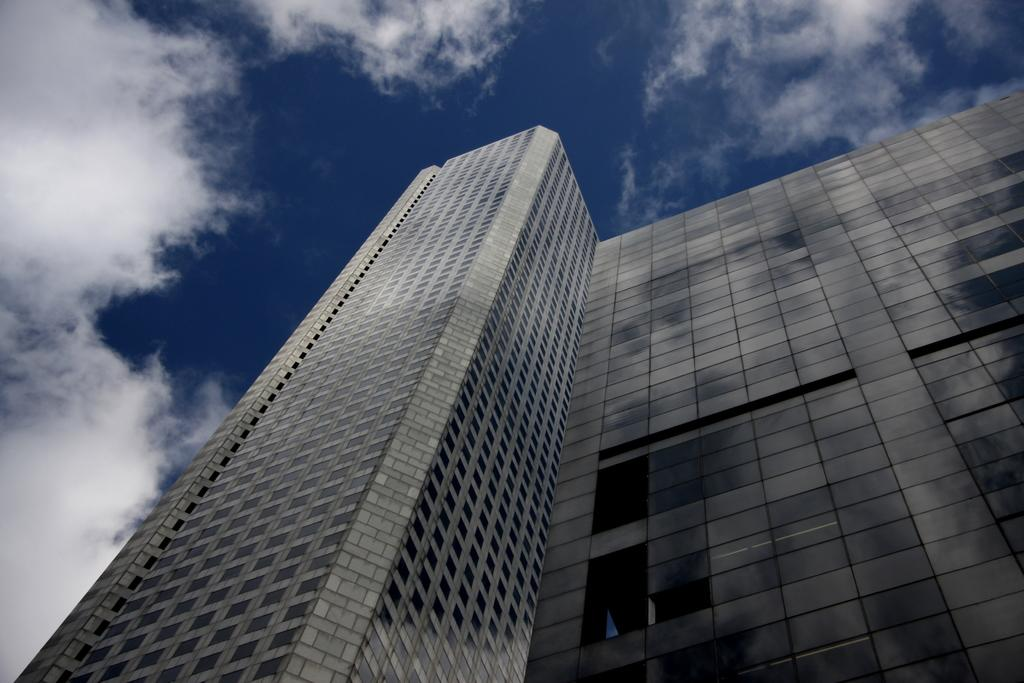What type of structure is present in the image? There is a building in the image. What can be seen above the building in the image? The sky is visible at the top of the image. What type of coil is used to cut the building in the image? There is no coil or cutting action present in the image; it simply shows a building and the sky. 